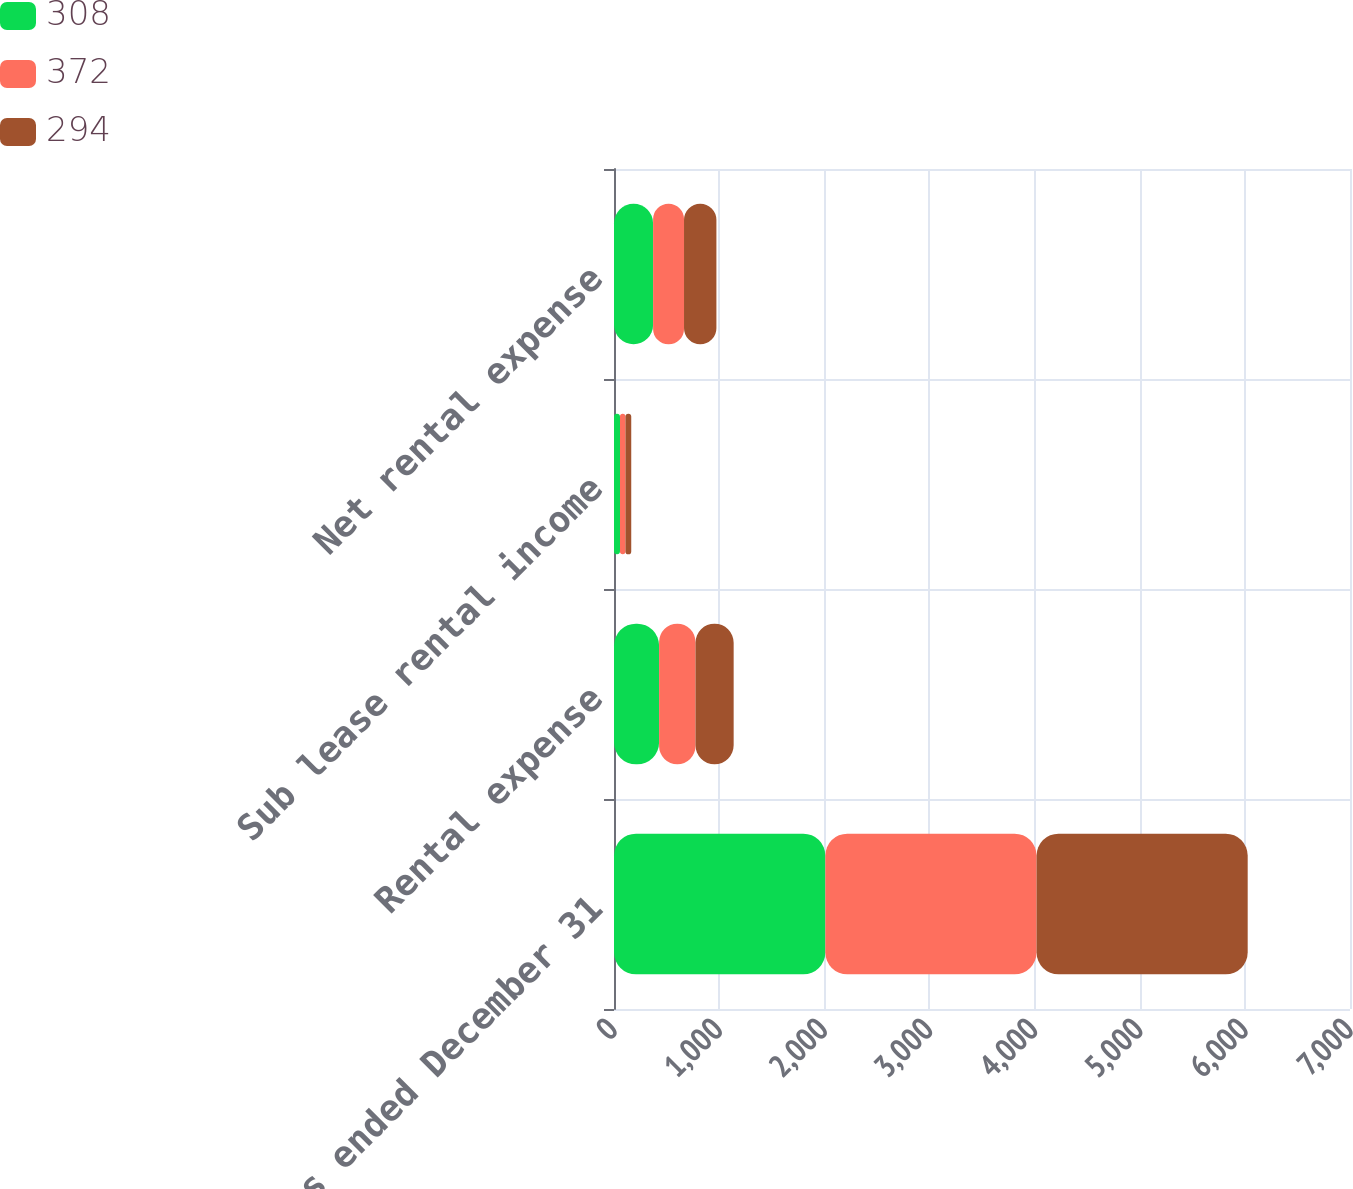<chart> <loc_0><loc_0><loc_500><loc_500><stacked_bar_chart><ecel><fcel>Years ended December 31<fcel>Rental expense<fcel>Sub lease rental income<fcel>Net rental expense<nl><fcel>308<fcel>2010<fcel>429<fcel>57<fcel>372<nl><fcel>372<fcel>2009<fcel>346<fcel>52<fcel>294<nl><fcel>294<fcel>2008<fcel>363<fcel>55<fcel>308<nl></chart> 